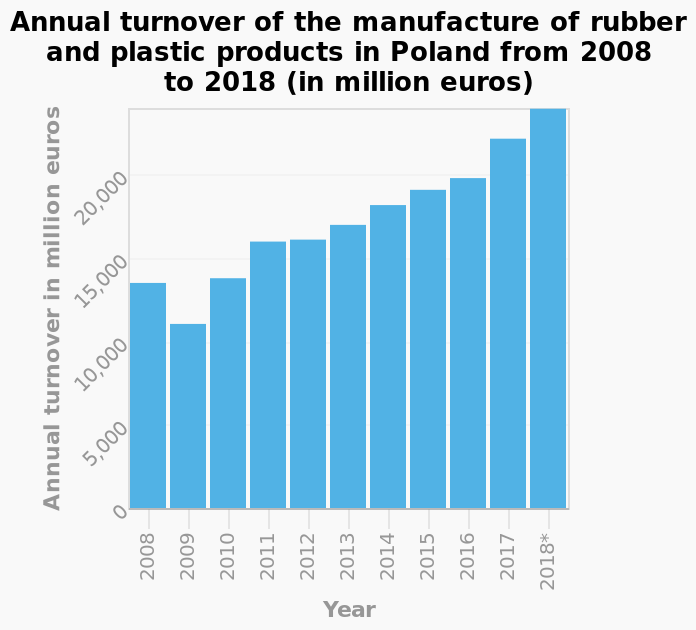<image>
What is the highest turnover achieved by the company? The company exceeded a turnover of 20.000 million Euros in 2018, which is its highest recorded turnover. What is the lowest value of annual turnover represented in the bar diagram? The lowest value of annual turnover represented in the bar diagram is 0 million euros. What is the scale of the y-axis in the bar diagram?  The scale of the y-axis in the bar diagram is linear. 